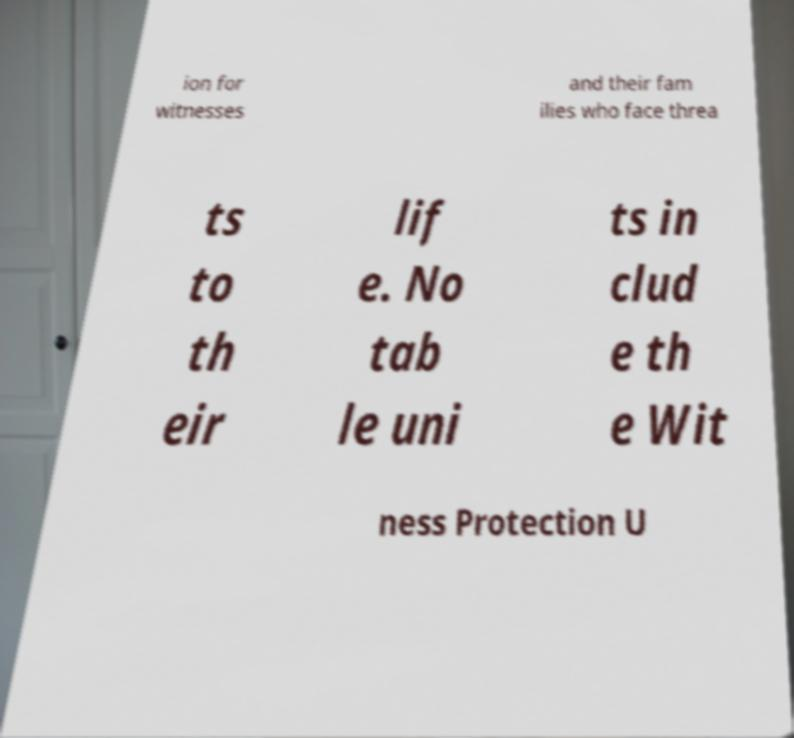Could you extract and type out the text from this image? ion for witnesses and their fam ilies who face threa ts to th eir lif e. No tab le uni ts in clud e th e Wit ness Protection U 